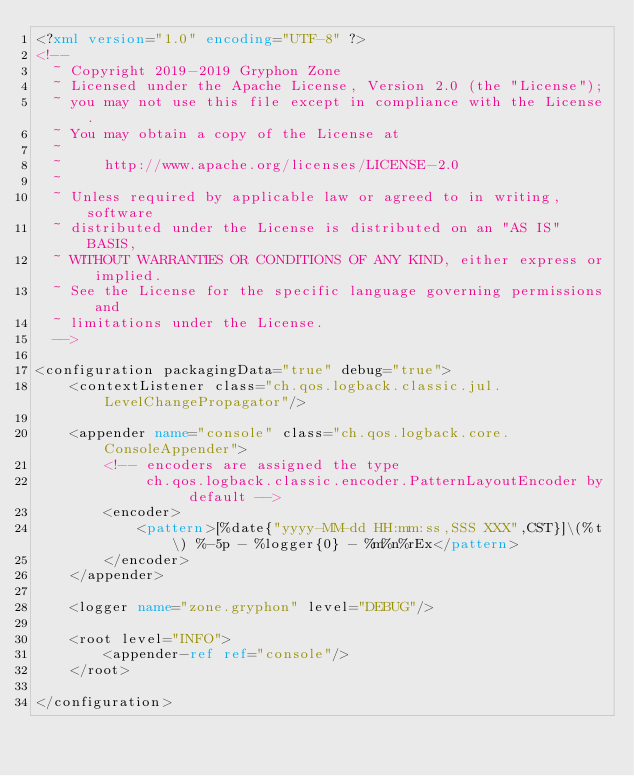Convert code to text. <code><loc_0><loc_0><loc_500><loc_500><_XML_><?xml version="1.0" encoding="UTF-8" ?>
<!--
  ~ Copyright 2019-2019 Gryphon Zone
  ~ Licensed under the Apache License, Version 2.0 (the "License");
  ~ you may not use this file except in compliance with the License.
  ~ You may obtain a copy of the License at
  ~
  ~     http://www.apache.org/licenses/LICENSE-2.0
  ~
  ~ Unless required by applicable law or agreed to in writing, software
  ~ distributed under the License is distributed on an "AS IS" BASIS,
  ~ WITHOUT WARRANTIES OR CONDITIONS OF ANY KIND, either express or implied.
  ~ See the License for the specific language governing permissions and
  ~ limitations under the License.
  -->

<configuration packagingData="true" debug="true">
    <contextListener class="ch.qos.logback.classic.jul.LevelChangePropagator"/>

    <appender name="console" class="ch.qos.logback.core.ConsoleAppender">
        <!-- encoders are assigned the type
             ch.qos.logback.classic.encoder.PatternLayoutEncoder by default -->
        <encoder>
            <pattern>[%date{"yyyy-MM-dd HH:mm:ss,SSS XXX",CST}]\(%t\) %-5p - %logger{0} - %m%n%rEx</pattern>
        </encoder>
    </appender>

    <logger name="zone.gryphon" level="DEBUG"/>

    <root level="INFO">
        <appender-ref ref="console"/>
    </root>

</configuration>
</code> 